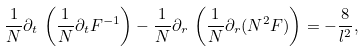<formula> <loc_0><loc_0><loc_500><loc_500>\frac { 1 } { N } \partial _ { t } \, \left ( \frac { 1 } { N } \partial _ { t } F ^ { - 1 } \right ) - \frac { 1 } { N } \partial _ { r } \, \left ( \frac { 1 } { N } \partial _ { r } ( N ^ { 2 } F ) \right ) = - \frac { 8 } { l ^ { 2 } } ,</formula> 